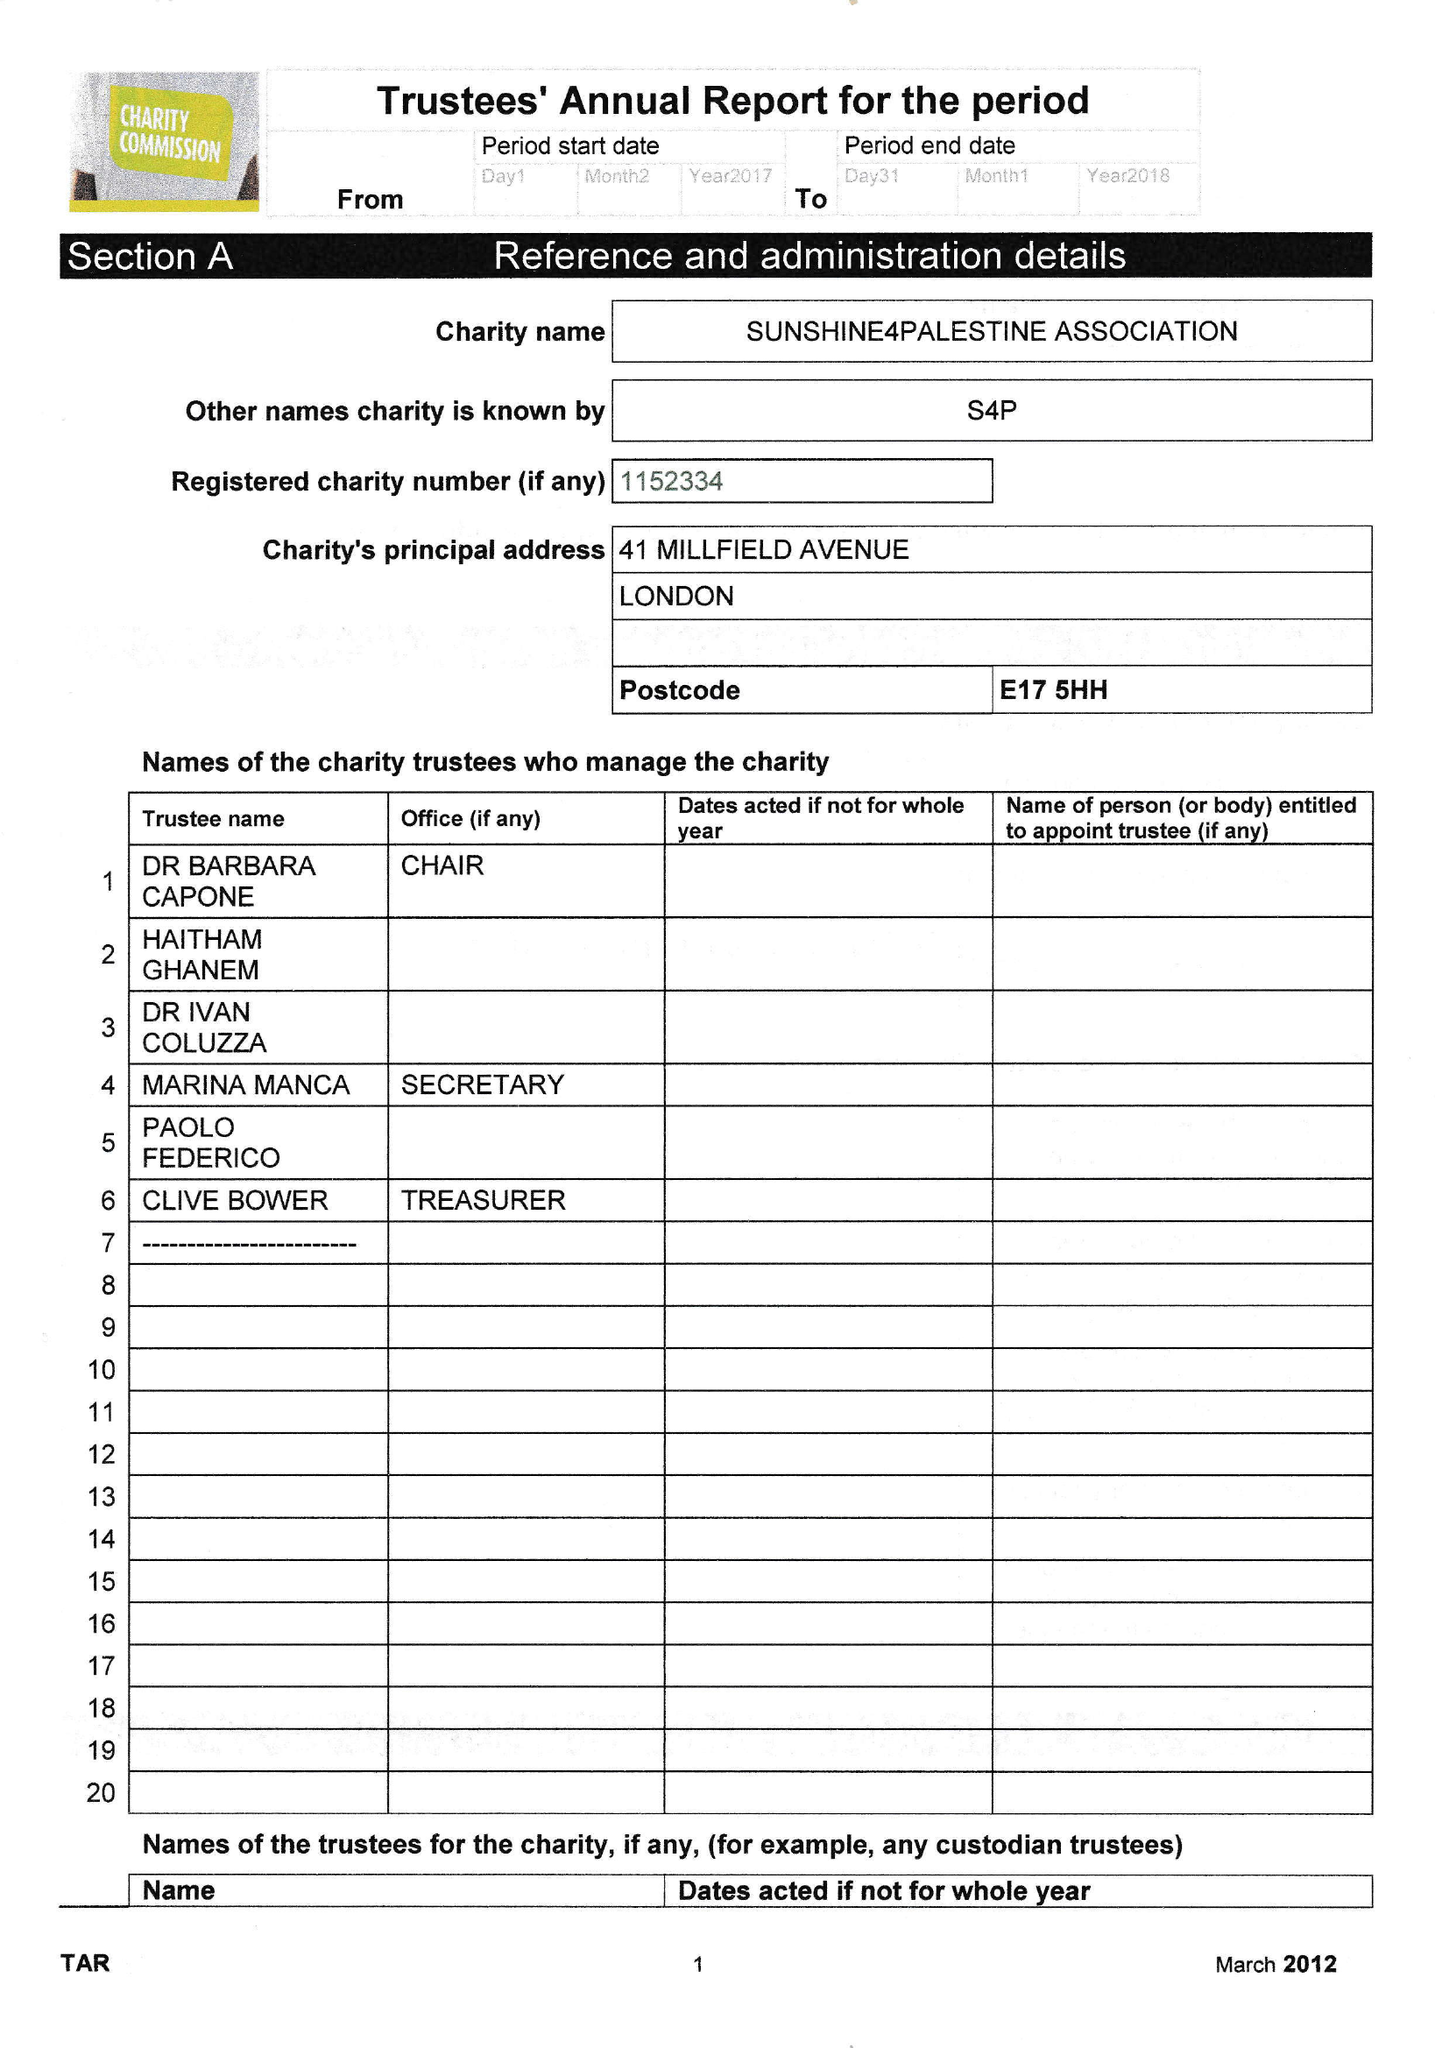What is the value for the charity_name?
Answer the question using a single word or phrase. Sunshine4palestine Association 